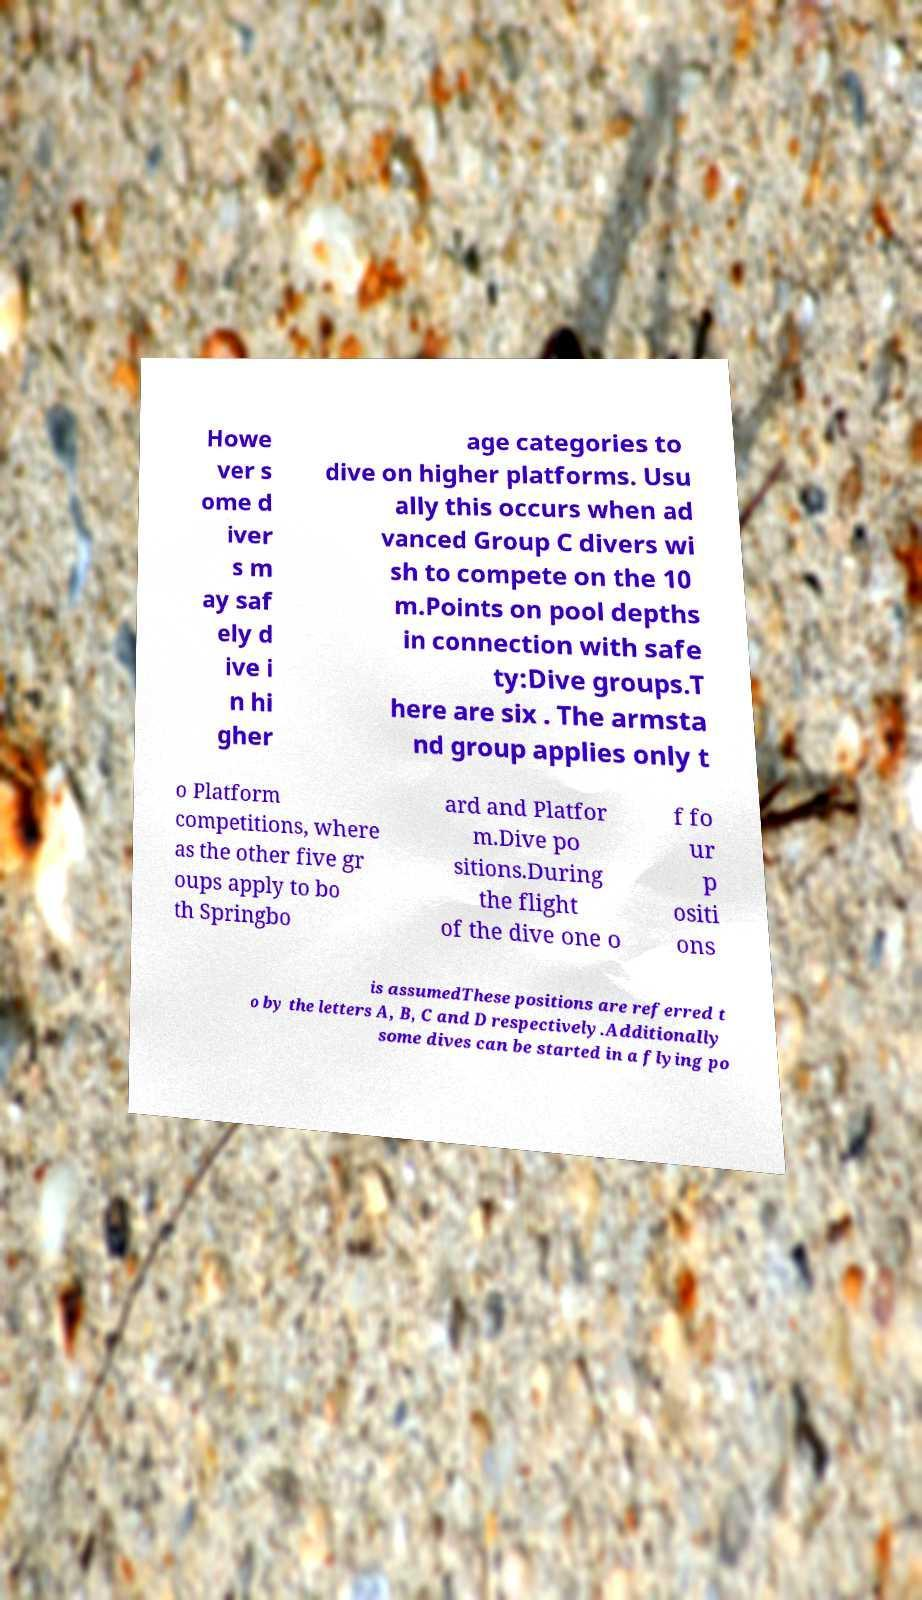For documentation purposes, I need the text within this image transcribed. Could you provide that? Howe ver s ome d iver s m ay saf ely d ive i n hi gher age categories to dive on higher platforms. Usu ally this occurs when ad vanced Group C divers wi sh to compete on the 10 m.Points on pool depths in connection with safe ty:Dive groups.T here are six . The armsta nd group applies only t o Platform competitions, where as the other five gr oups apply to bo th Springbo ard and Platfor m.Dive po sitions.During the flight of the dive one o f fo ur p ositi ons is assumedThese positions are referred t o by the letters A, B, C and D respectively.Additionally some dives can be started in a flying po 